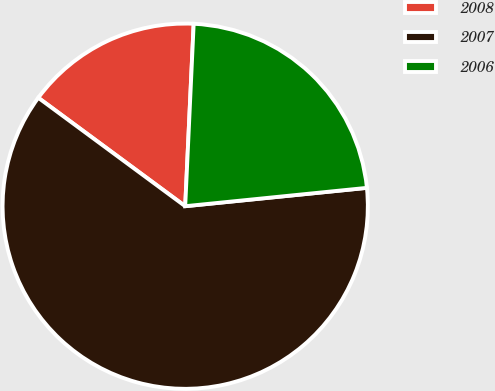<chart> <loc_0><loc_0><loc_500><loc_500><pie_chart><fcel>2008<fcel>2007<fcel>2006<nl><fcel>15.62%<fcel>61.72%<fcel>22.66%<nl></chart> 